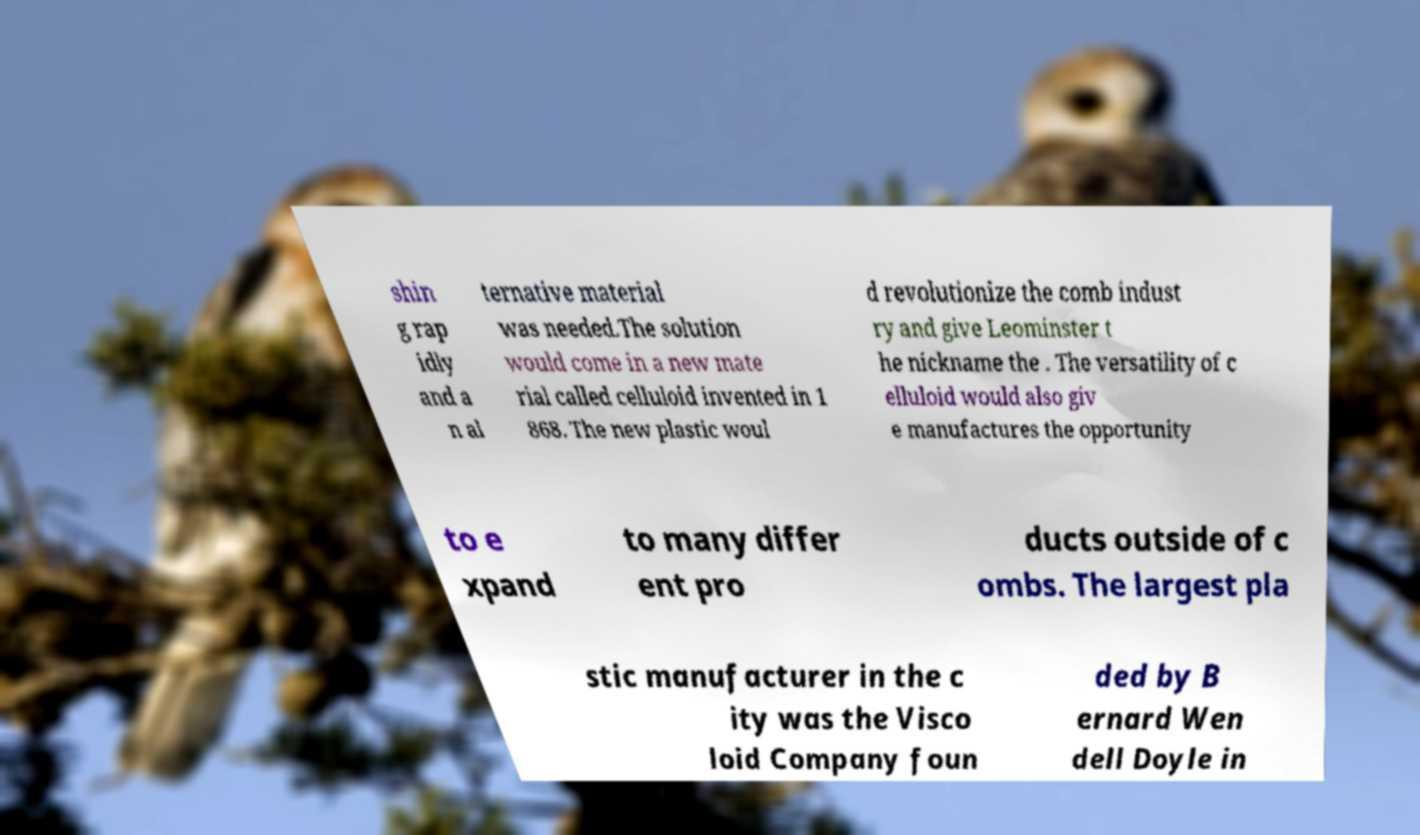There's text embedded in this image that I need extracted. Can you transcribe it verbatim? shin g rap idly and a n al ternative material was needed.The solution would come in a new mate rial called celluloid invented in 1 868. The new plastic woul d revolutionize the comb indust ry and give Leominster t he nickname the . The versatility of c elluloid would also giv e manufactures the opportunity to e xpand to many differ ent pro ducts outside of c ombs. The largest pla stic manufacturer in the c ity was the Visco loid Company foun ded by B ernard Wen dell Doyle in 